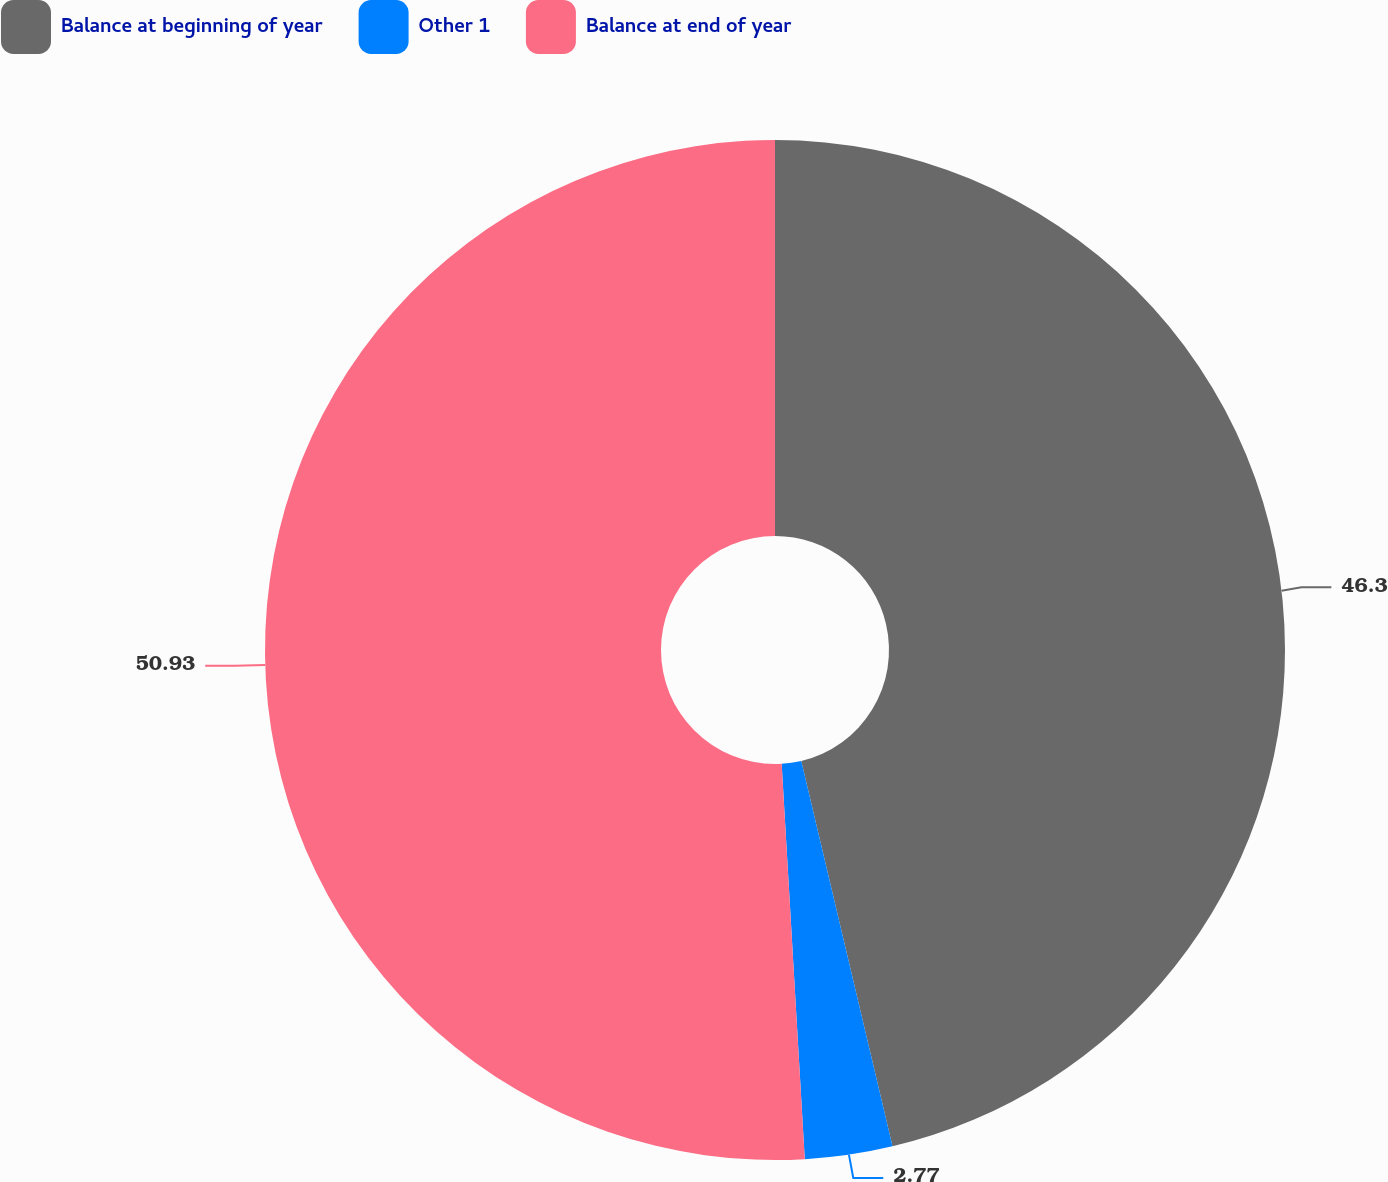<chart> <loc_0><loc_0><loc_500><loc_500><pie_chart><fcel>Balance at beginning of year<fcel>Other 1<fcel>Balance at end of year<nl><fcel>46.3%<fcel>2.77%<fcel>50.93%<nl></chart> 